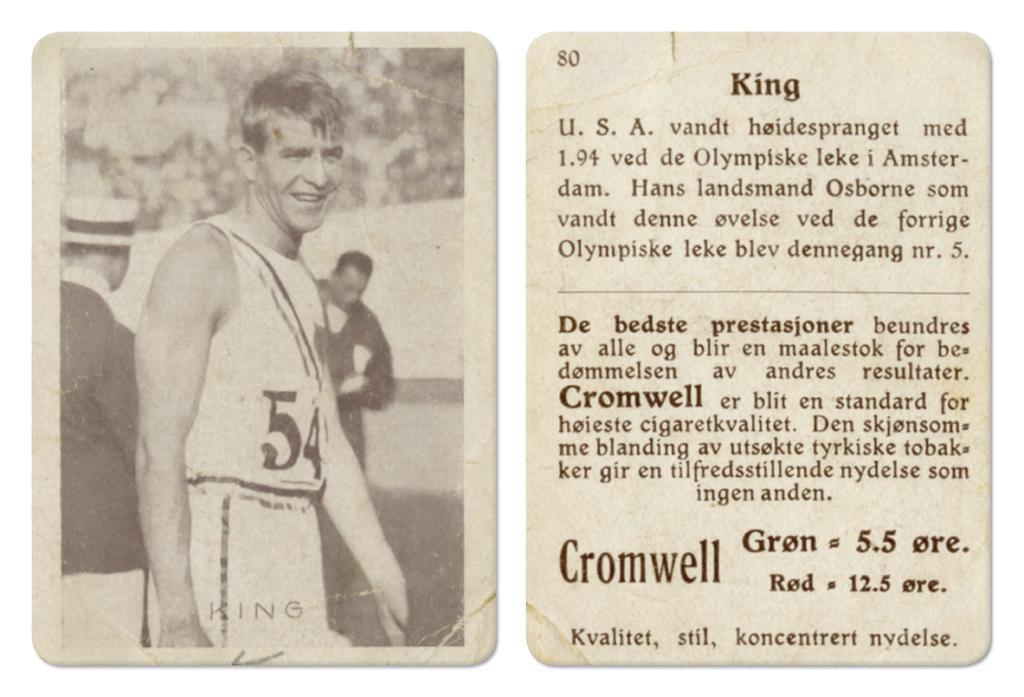Could you give a brief overview of what you see in this image? There are two posters. In the first poster, there is a person smiling and standing. In the background, there are two persons. And the background of this image is blurred. In the second image, there are texts and numbers on it. 